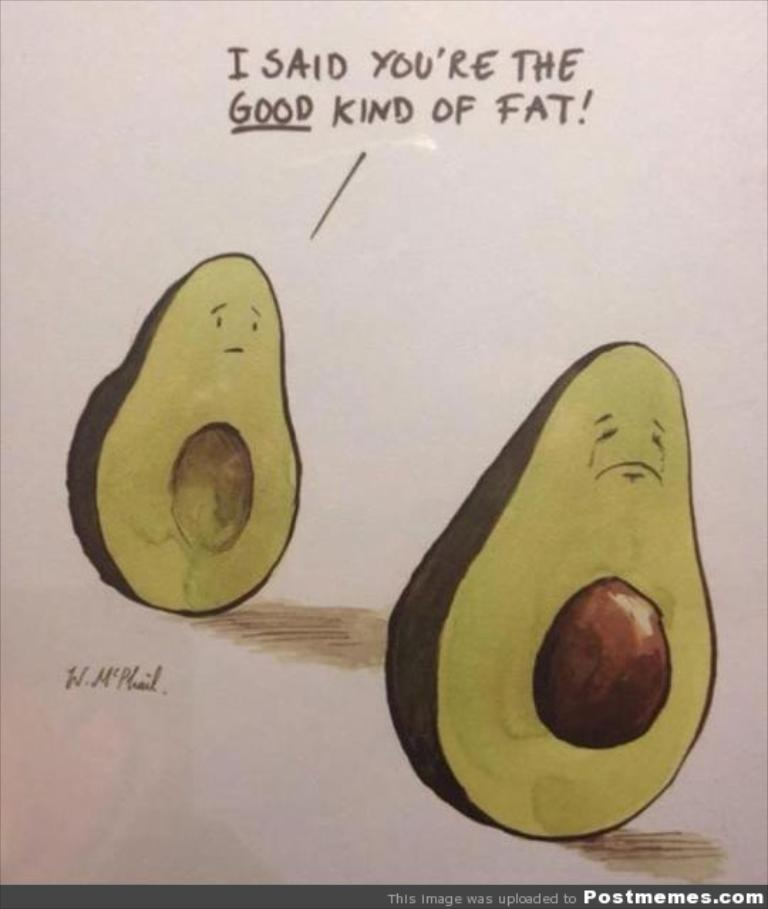What type of artwork is shown in the image? The image appears to be a painting. What food items are depicted in the painting? There are two pieces of avocado depicted in the painting. Are there any words or marks on the painting? Yes, there are letters and a signature on the painting. What additional detail can be seen at the bottom of the image? There is a watermark at the bottom of the image. How many cows are depicted in the painting? There are no cows depicted in the painting; it features two pieces of avocado. What type of food is being prepared by the sisters in the painting? There are no sisters or food preparation depicted in the painting; it only shows two pieces of avocado. 